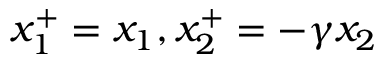Convert formula to latex. <formula><loc_0><loc_0><loc_500><loc_500>x _ { 1 } ^ { + } = x _ { 1 } , x _ { 2 } ^ { + } = - \gamma x _ { 2 }</formula> 